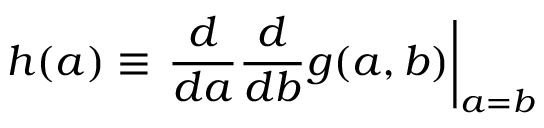Convert formula to latex. <formula><loc_0><loc_0><loc_500><loc_500>h ( a ) \equiv { \frac { d } { d a } } { \frac { d } { d b } } g ( a , b ) \right | _ { a = b }</formula> 